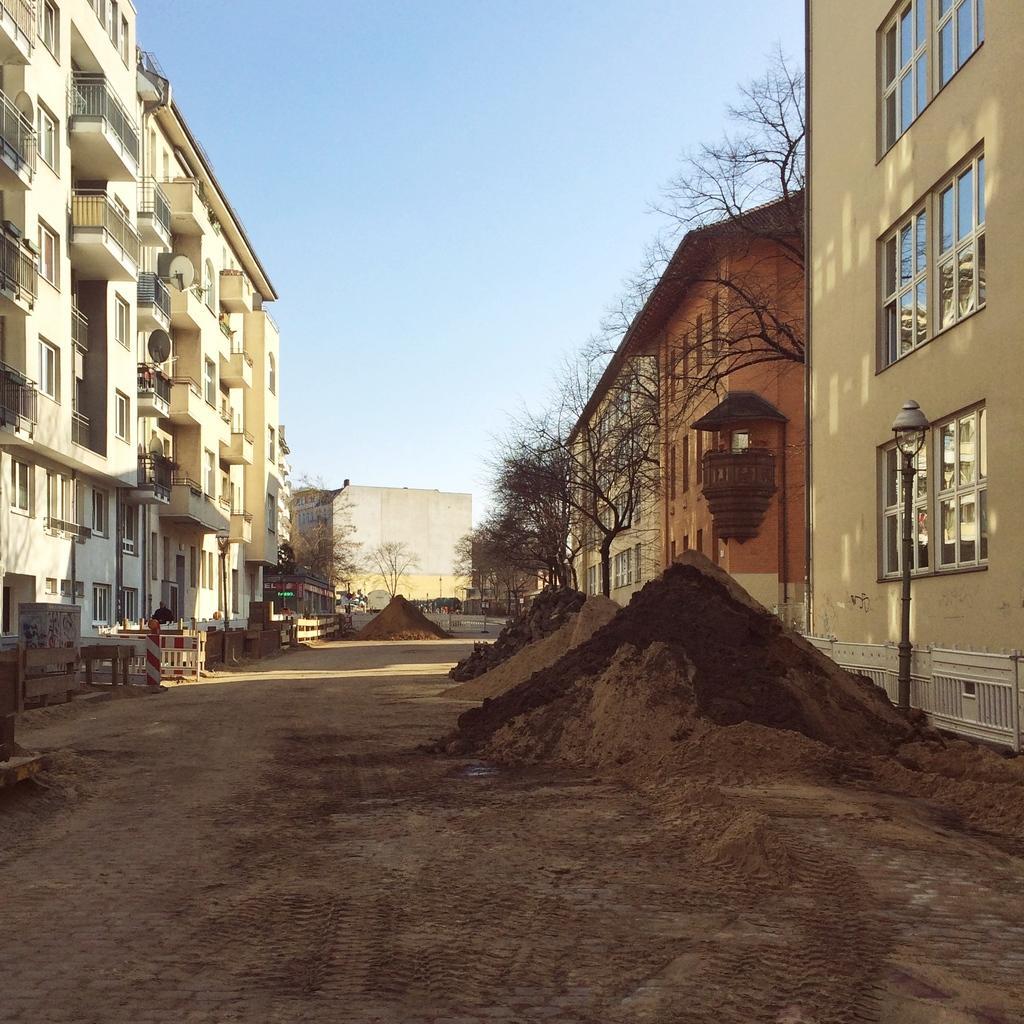Please provide a concise description of this image. In this image there are buildings on the left side there is a woman standing in front of the building and on the right side there are buildings trees and there is a pole. In the center there is sand on the ground. 